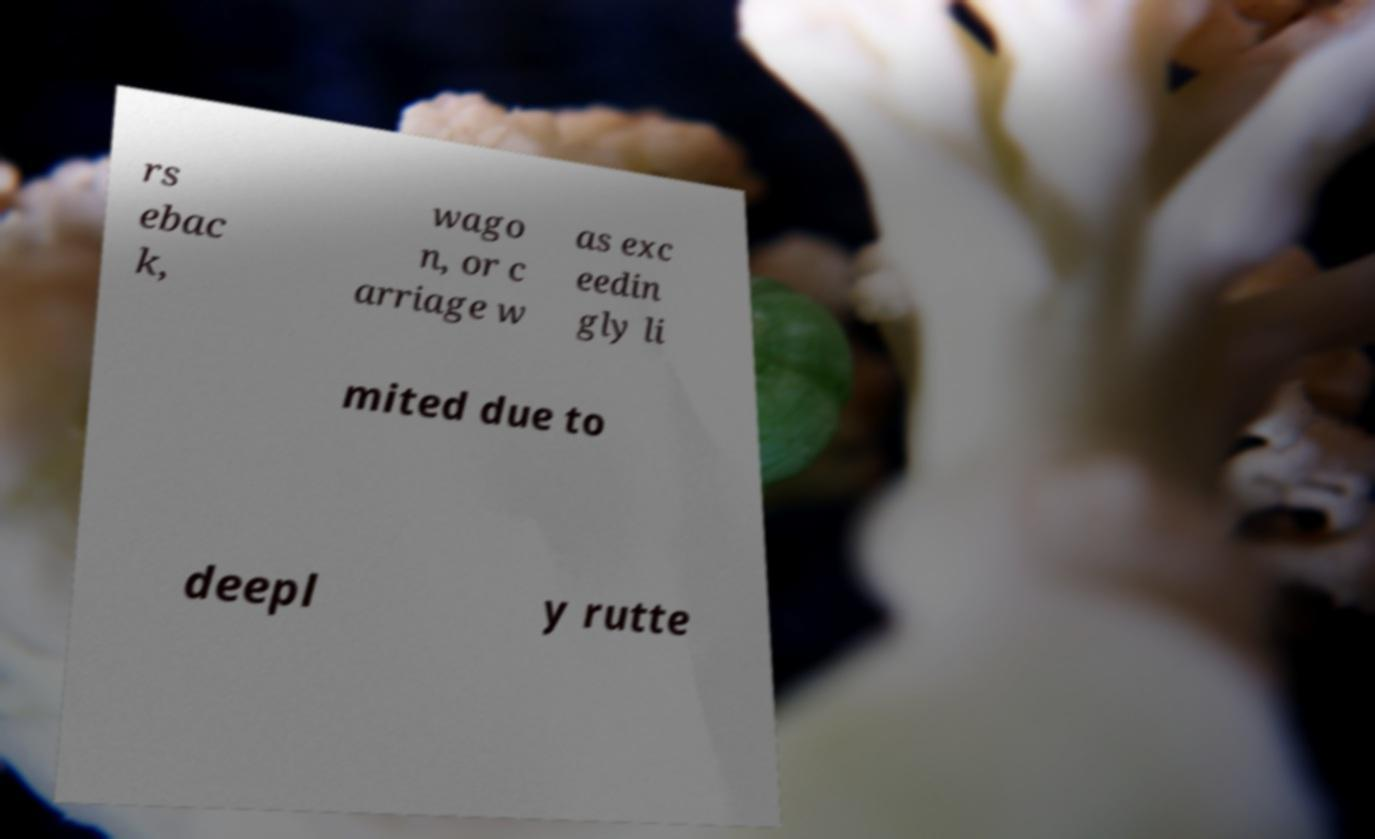What messages or text are displayed in this image? I need them in a readable, typed format. rs ebac k, wago n, or c arriage w as exc eedin gly li mited due to deepl y rutte 